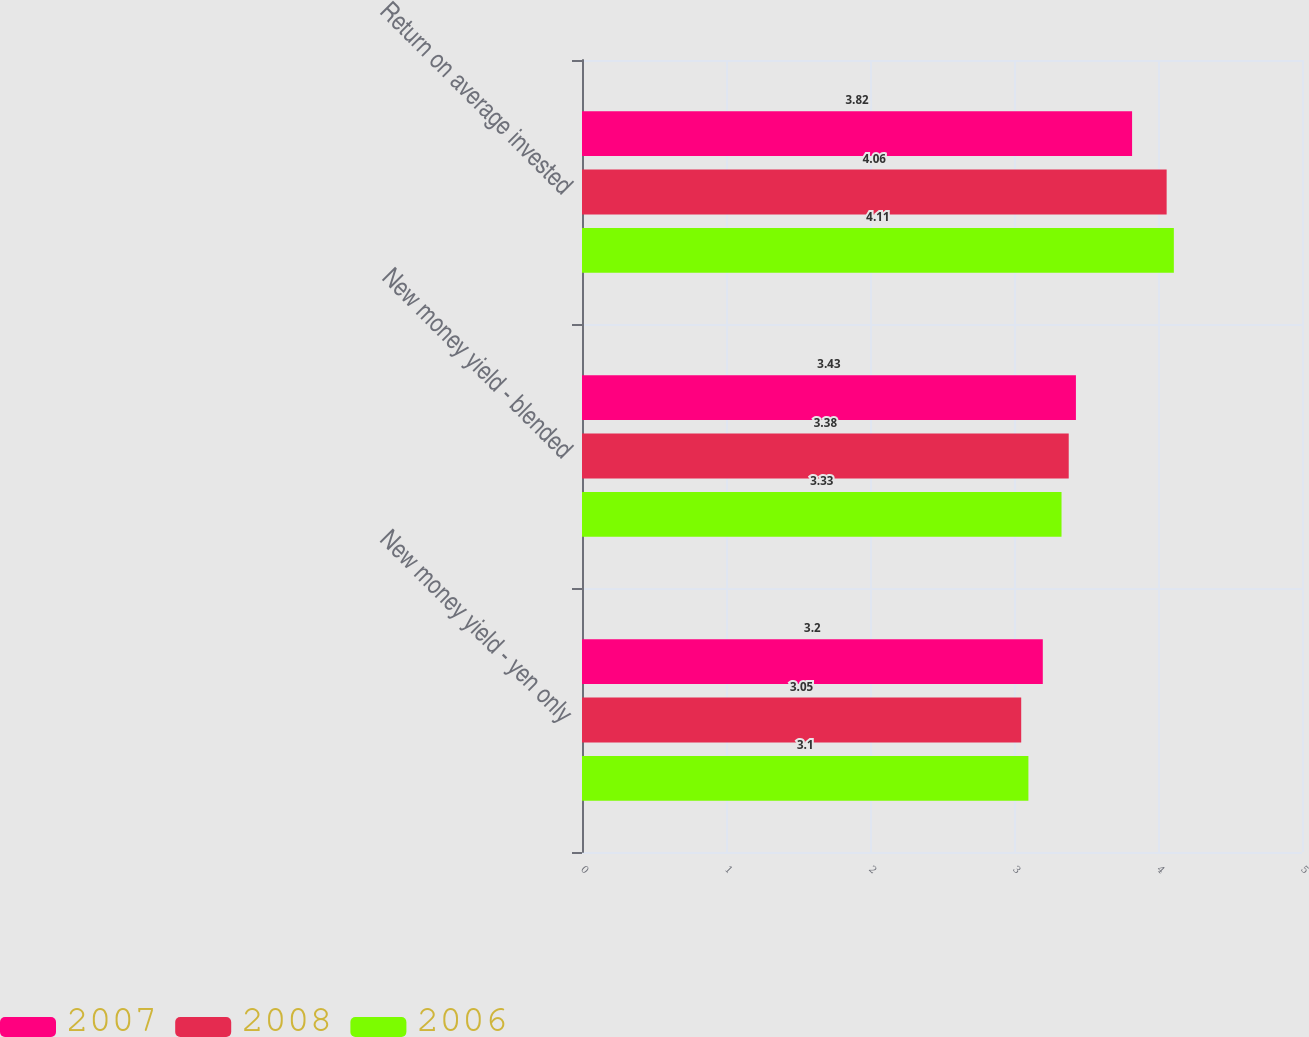Convert chart to OTSL. <chart><loc_0><loc_0><loc_500><loc_500><stacked_bar_chart><ecel><fcel>New money yield - yen only<fcel>New money yield - blended<fcel>Return on average invested<nl><fcel>2007<fcel>3.2<fcel>3.43<fcel>3.82<nl><fcel>2008<fcel>3.05<fcel>3.38<fcel>4.06<nl><fcel>2006<fcel>3.1<fcel>3.33<fcel>4.11<nl></chart> 